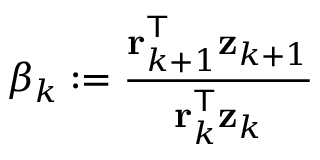<formula> <loc_0><loc_0><loc_500><loc_500>\beta _ { k } \colon = { \frac { r _ { k + 1 } ^ { T } z _ { k + 1 } } { r _ { k } ^ { T } z _ { k } } }</formula> 